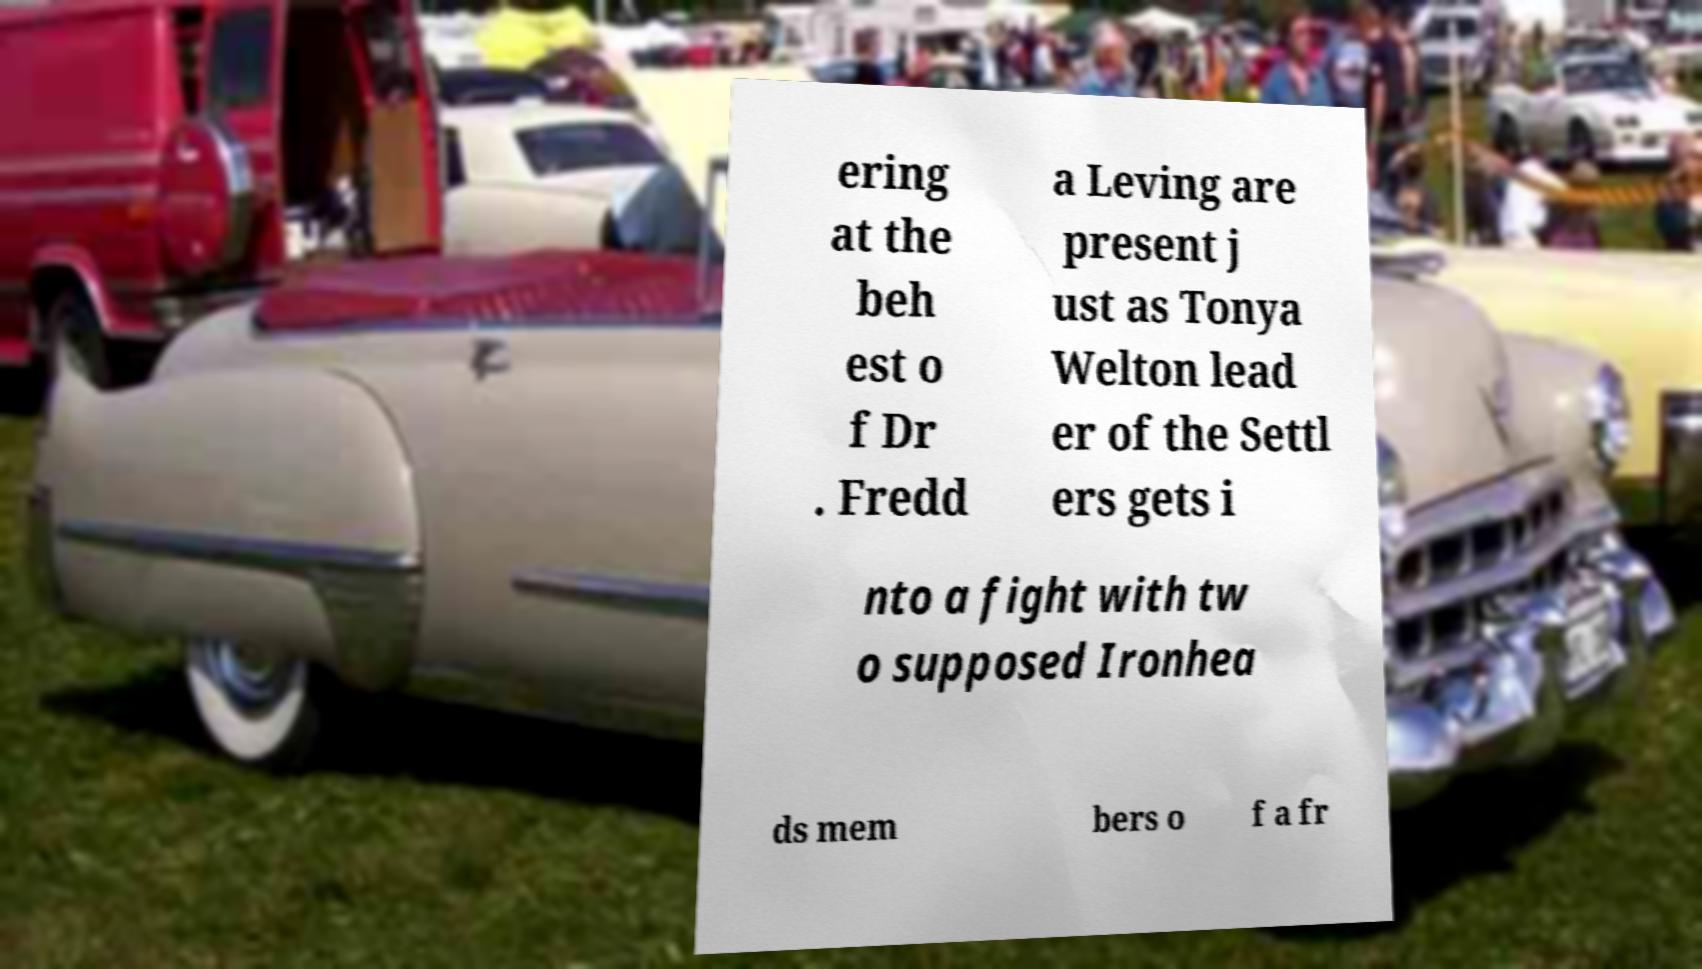Can you read and provide the text displayed in the image?This photo seems to have some interesting text. Can you extract and type it out for me? ering at the beh est o f Dr . Fredd a Leving are present j ust as Tonya Welton lead er of the Settl ers gets i nto a fight with tw o supposed Ironhea ds mem bers o f a fr 